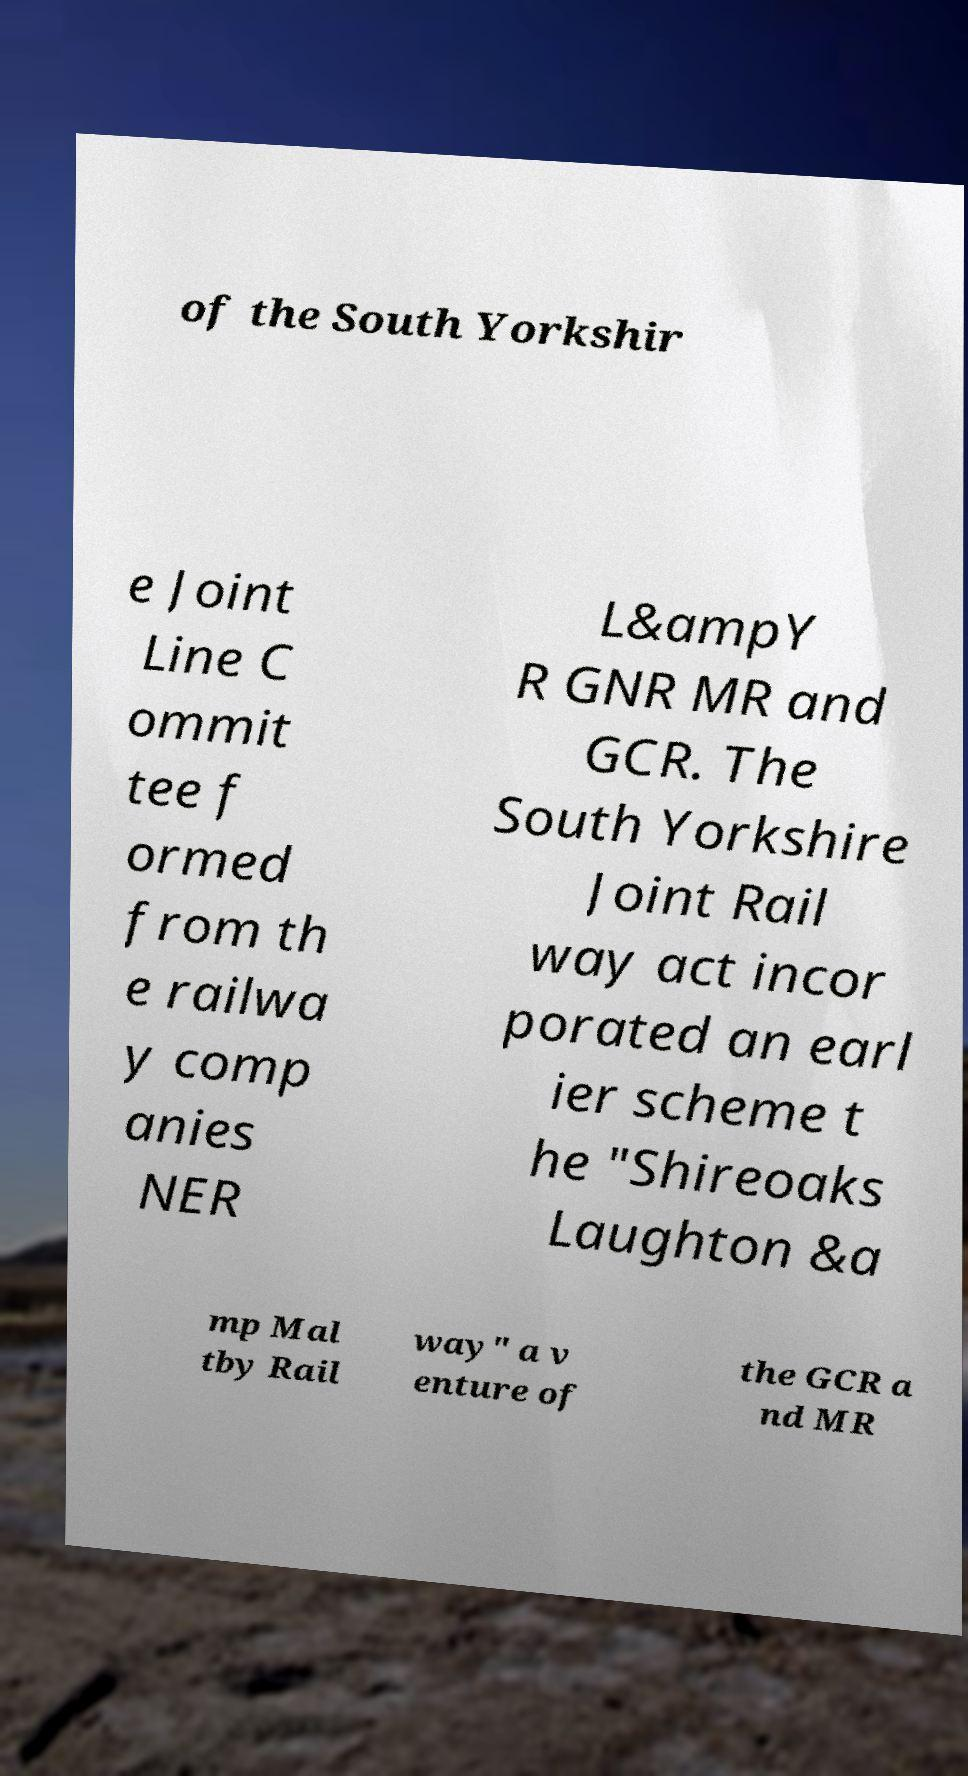Please identify and transcribe the text found in this image. of the South Yorkshir e Joint Line C ommit tee f ormed from th e railwa y comp anies NER L&ampY R GNR MR and GCR. The South Yorkshire Joint Rail way act incor porated an earl ier scheme t he "Shireoaks Laughton &a mp Mal tby Rail way" a v enture of the GCR a nd MR 